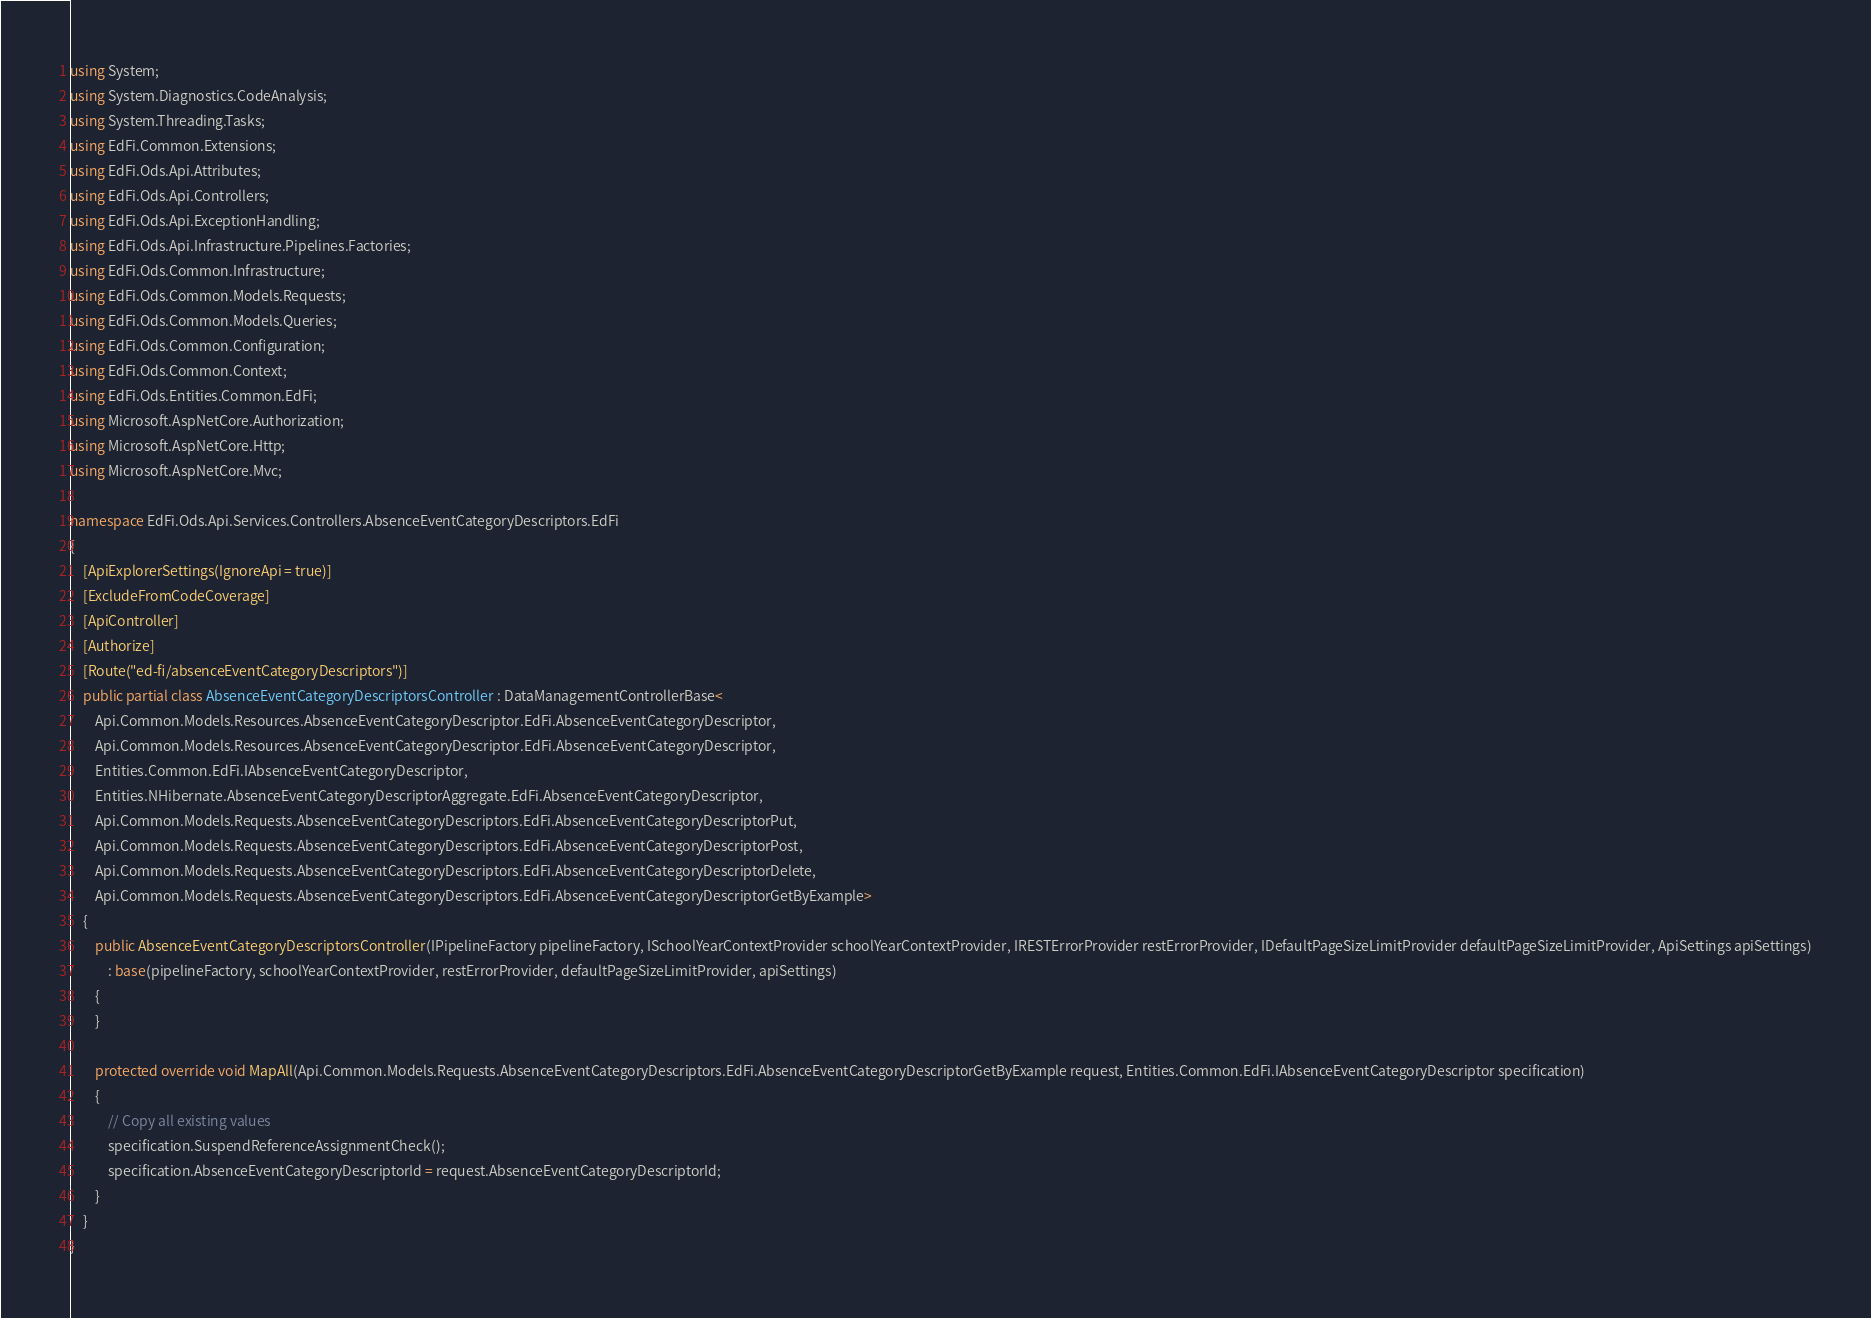<code> <loc_0><loc_0><loc_500><loc_500><_C#_>using System;
using System.Diagnostics.CodeAnalysis;
using System.Threading.Tasks;
using EdFi.Common.Extensions;
using EdFi.Ods.Api.Attributes;
using EdFi.Ods.Api.Controllers;
using EdFi.Ods.Api.ExceptionHandling;
using EdFi.Ods.Api.Infrastructure.Pipelines.Factories;
using EdFi.Ods.Common.Infrastructure;
using EdFi.Ods.Common.Models.Requests;
using EdFi.Ods.Common.Models.Queries;
using EdFi.Ods.Common.Configuration;
using EdFi.Ods.Common.Context;
using EdFi.Ods.Entities.Common.EdFi;
using Microsoft.AspNetCore.Authorization;
using Microsoft.AspNetCore.Http;
using Microsoft.AspNetCore.Mvc;

namespace EdFi.Ods.Api.Services.Controllers.AbsenceEventCategoryDescriptors.EdFi
{
    [ApiExplorerSettings(IgnoreApi = true)]
    [ExcludeFromCodeCoverage]
    [ApiController]
    [Authorize]
    [Route("ed-fi/absenceEventCategoryDescriptors")]
    public partial class AbsenceEventCategoryDescriptorsController : DataManagementControllerBase<
        Api.Common.Models.Resources.AbsenceEventCategoryDescriptor.EdFi.AbsenceEventCategoryDescriptor,
        Api.Common.Models.Resources.AbsenceEventCategoryDescriptor.EdFi.AbsenceEventCategoryDescriptor,
        Entities.Common.EdFi.IAbsenceEventCategoryDescriptor,
        Entities.NHibernate.AbsenceEventCategoryDescriptorAggregate.EdFi.AbsenceEventCategoryDescriptor,
        Api.Common.Models.Requests.AbsenceEventCategoryDescriptors.EdFi.AbsenceEventCategoryDescriptorPut,
        Api.Common.Models.Requests.AbsenceEventCategoryDescriptors.EdFi.AbsenceEventCategoryDescriptorPost,
        Api.Common.Models.Requests.AbsenceEventCategoryDescriptors.EdFi.AbsenceEventCategoryDescriptorDelete,
        Api.Common.Models.Requests.AbsenceEventCategoryDescriptors.EdFi.AbsenceEventCategoryDescriptorGetByExample>
    {
        public AbsenceEventCategoryDescriptorsController(IPipelineFactory pipelineFactory, ISchoolYearContextProvider schoolYearContextProvider, IRESTErrorProvider restErrorProvider, IDefaultPageSizeLimitProvider defaultPageSizeLimitProvider, ApiSettings apiSettings)
            : base(pipelineFactory, schoolYearContextProvider, restErrorProvider, defaultPageSizeLimitProvider, apiSettings)
        {
        }

        protected override void MapAll(Api.Common.Models.Requests.AbsenceEventCategoryDescriptors.EdFi.AbsenceEventCategoryDescriptorGetByExample request, Entities.Common.EdFi.IAbsenceEventCategoryDescriptor specification)
        {
            // Copy all existing values
            specification.SuspendReferenceAssignmentCheck();
            specification.AbsenceEventCategoryDescriptorId = request.AbsenceEventCategoryDescriptorId;
        }
    }
}
</code> 